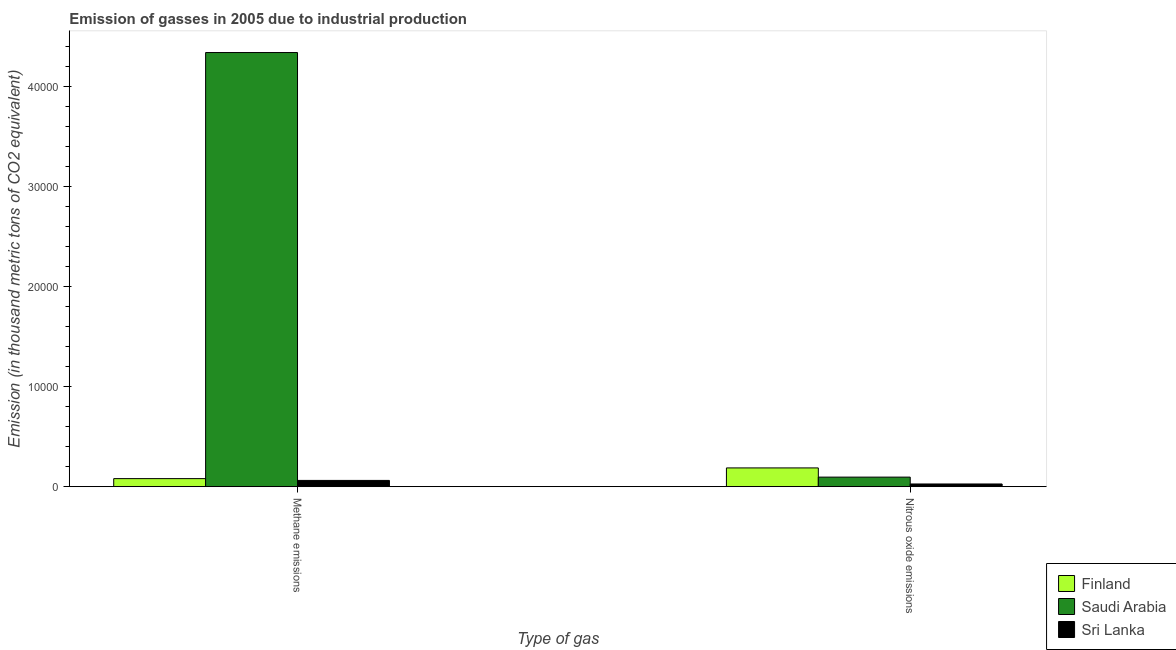How many groups of bars are there?
Your response must be concise. 2. Are the number of bars per tick equal to the number of legend labels?
Your answer should be very brief. Yes. Are the number of bars on each tick of the X-axis equal?
Keep it short and to the point. Yes. How many bars are there on the 1st tick from the left?
Give a very brief answer. 3. What is the label of the 1st group of bars from the left?
Provide a short and direct response. Methane emissions. What is the amount of methane emissions in Finland?
Keep it short and to the point. 806.6. Across all countries, what is the maximum amount of nitrous oxide emissions?
Make the answer very short. 1876.3. Across all countries, what is the minimum amount of nitrous oxide emissions?
Give a very brief answer. 271.8. In which country was the amount of methane emissions maximum?
Your answer should be very brief. Saudi Arabia. In which country was the amount of methane emissions minimum?
Offer a terse response. Sri Lanka. What is the total amount of methane emissions in the graph?
Your answer should be very brief. 4.48e+04. What is the difference between the amount of nitrous oxide emissions in Saudi Arabia and that in Sri Lanka?
Provide a short and direct response. 684.9. What is the difference between the amount of nitrous oxide emissions in Finland and the amount of methane emissions in Sri Lanka?
Offer a terse response. 1249. What is the average amount of nitrous oxide emissions per country?
Provide a succinct answer. 1034.93. What is the difference between the amount of nitrous oxide emissions and amount of methane emissions in Saudi Arabia?
Your answer should be very brief. -4.24e+04. In how many countries, is the amount of nitrous oxide emissions greater than 2000 thousand metric tons?
Make the answer very short. 0. What is the ratio of the amount of nitrous oxide emissions in Finland to that in Sri Lanka?
Make the answer very short. 6.9. Is the amount of methane emissions in Sri Lanka less than that in Finland?
Your answer should be very brief. Yes. In how many countries, is the amount of nitrous oxide emissions greater than the average amount of nitrous oxide emissions taken over all countries?
Provide a succinct answer. 1. What does the 3rd bar from the left in Nitrous oxide emissions represents?
Your response must be concise. Sri Lanka. What does the 2nd bar from the right in Methane emissions represents?
Give a very brief answer. Saudi Arabia. Are all the bars in the graph horizontal?
Your response must be concise. No. What is the difference between two consecutive major ticks on the Y-axis?
Ensure brevity in your answer.  10000. Are the values on the major ticks of Y-axis written in scientific E-notation?
Your answer should be compact. No. Does the graph contain any zero values?
Provide a succinct answer. No. Does the graph contain grids?
Ensure brevity in your answer.  No. How many legend labels are there?
Keep it short and to the point. 3. What is the title of the graph?
Offer a very short reply. Emission of gasses in 2005 due to industrial production. What is the label or title of the X-axis?
Offer a terse response. Type of gas. What is the label or title of the Y-axis?
Your answer should be compact. Emission (in thousand metric tons of CO2 equivalent). What is the Emission (in thousand metric tons of CO2 equivalent) of Finland in Methane emissions?
Your answer should be very brief. 806.6. What is the Emission (in thousand metric tons of CO2 equivalent) in Saudi Arabia in Methane emissions?
Offer a terse response. 4.34e+04. What is the Emission (in thousand metric tons of CO2 equivalent) in Sri Lanka in Methane emissions?
Your response must be concise. 627.3. What is the Emission (in thousand metric tons of CO2 equivalent) in Finland in Nitrous oxide emissions?
Keep it short and to the point. 1876.3. What is the Emission (in thousand metric tons of CO2 equivalent) in Saudi Arabia in Nitrous oxide emissions?
Your answer should be very brief. 956.7. What is the Emission (in thousand metric tons of CO2 equivalent) of Sri Lanka in Nitrous oxide emissions?
Offer a very short reply. 271.8. Across all Type of gas, what is the maximum Emission (in thousand metric tons of CO2 equivalent) in Finland?
Offer a terse response. 1876.3. Across all Type of gas, what is the maximum Emission (in thousand metric tons of CO2 equivalent) in Saudi Arabia?
Your response must be concise. 4.34e+04. Across all Type of gas, what is the maximum Emission (in thousand metric tons of CO2 equivalent) of Sri Lanka?
Your answer should be compact. 627.3. Across all Type of gas, what is the minimum Emission (in thousand metric tons of CO2 equivalent) in Finland?
Keep it short and to the point. 806.6. Across all Type of gas, what is the minimum Emission (in thousand metric tons of CO2 equivalent) of Saudi Arabia?
Provide a succinct answer. 956.7. Across all Type of gas, what is the minimum Emission (in thousand metric tons of CO2 equivalent) of Sri Lanka?
Give a very brief answer. 271.8. What is the total Emission (in thousand metric tons of CO2 equivalent) in Finland in the graph?
Provide a short and direct response. 2682.9. What is the total Emission (in thousand metric tons of CO2 equivalent) in Saudi Arabia in the graph?
Your answer should be compact. 4.44e+04. What is the total Emission (in thousand metric tons of CO2 equivalent) of Sri Lanka in the graph?
Your answer should be compact. 899.1. What is the difference between the Emission (in thousand metric tons of CO2 equivalent) in Finland in Methane emissions and that in Nitrous oxide emissions?
Offer a very short reply. -1069.7. What is the difference between the Emission (in thousand metric tons of CO2 equivalent) of Saudi Arabia in Methane emissions and that in Nitrous oxide emissions?
Offer a terse response. 4.24e+04. What is the difference between the Emission (in thousand metric tons of CO2 equivalent) of Sri Lanka in Methane emissions and that in Nitrous oxide emissions?
Offer a terse response. 355.5. What is the difference between the Emission (in thousand metric tons of CO2 equivalent) of Finland in Methane emissions and the Emission (in thousand metric tons of CO2 equivalent) of Saudi Arabia in Nitrous oxide emissions?
Offer a terse response. -150.1. What is the difference between the Emission (in thousand metric tons of CO2 equivalent) of Finland in Methane emissions and the Emission (in thousand metric tons of CO2 equivalent) of Sri Lanka in Nitrous oxide emissions?
Make the answer very short. 534.8. What is the difference between the Emission (in thousand metric tons of CO2 equivalent) in Saudi Arabia in Methane emissions and the Emission (in thousand metric tons of CO2 equivalent) in Sri Lanka in Nitrous oxide emissions?
Make the answer very short. 4.31e+04. What is the average Emission (in thousand metric tons of CO2 equivalent) of Finland per Type of gas?
Offer a very short reply. 1341.45. What is the average Emission (in thousand metric tons of CO2 equivalent) in Saudi Arabia per Type of gas?
Provide a succinct answer. 2.22e+04. What is the average Emission (in thousand metric tons of CO2 equivalent) in Sri Lanka per Type of gas?
Your response must be concise. 449.55. What is the difference between the Emission (in thousand metric tons of CO2 equivalent) in Finland and Emission (in thousand metric tons of CO2 equivalent) in Saudi Arabia in Methane emissions?
Offer a terse response. -4.26e+04. What is the difference between the Emission (in thousand metric tons of CO2 equivalent) of Finland and Emission (in thousand metric tons of CO2 equivalent) of Sri Lanka in Methane emissions?
Give a very brief answer. 179.3. What is the difference between the Emission (in thousand metric tons of CO2 equivalent) of Saudi Arabia and Emission (in thousand metric tons of CO2 equivalent) of Sri Lanka in Methane emissions?
Offer a very short reply. 4.28e+04. What is the difference between the Emission (in thousand metric tons of CO2 equivalent) of Finland and Emission (in thousand metric tons of CO2 equivalent) of Saudi Arabia in Nitrous oxide emissions?
Give a very brief answer. 919.6. What is the difference between the Emission (in thousand metric tons of CO2 equivalent) of Finland and Emission (in thousand metric tons of CO2 equivalent) of Sri Lanka in Nitrous oxide emissions?
Your answer should be compact. 1604.5. What is the difference between the Emission (in thousand metric tons of CO2 equivalent) in Saudi Arabia and Emission (in thousand metric tons of CO2 equivalent) in Sri Lanka in Nitrous oxide emissions?
Give a very brief answer. 684.9. What is the ratio of the Emission (in thousand metric tons of CO2 equivalent) in Finland in Methane emissions to that in Nitrous oxide emissions?
Offer a terse response. 0.43. What is the ratio of the Emission (in thousand metric tons of CO2 equivalent) of Saudi Arabia in Methane emissions to that in Nitrous oxide emissions?
Ensure brevity in your answer.  45.36. What is the ratio of the Emission (in thousand metric tons of CO2 equivalent) of Sri Lanka in Methane emissions to that in Nitrous oxide emissions?
Your answer should be compact. 2.31. What is the difference between the highest and the second highest Emission (in thousand metric tons of CO2 equivalent) in Finland?
Your answer should be very brief. 1069.7. What is the difference between the highest and the second highest Emission (in thousand metric tons of CO2 equivalent) of Saudi Arabia?
Your response must be concise. 4.24e+04. What is the difference between the highest and the second highest Emission (in thousand metric tons of CO2 equivalent) of Sri Lanka?
Offer a terse response. 355.5. What is the difference between the highest and the lowest Emission (in thousand metric tons of CO2 equivalent) in Finland?
Provide a succinct answer. 1069.7. What is the difference between the highest and the lowest Emission (in thousand metric tons of CO2 equivalent) of Saudi Arabia?
Provide a succinct answer. 4.24e+04. What is the difference between the highest and the lowest Emission (in thousand metric tons of CO2 equivalent) of Sri Lanka?
Provide a succinct answer. 355.5. 